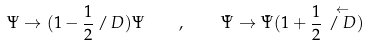Convert formula to latex. <formula><loc_0><loc_0><loc_500><loc_500>\Psi \rightarrow ( 1 - \frac { 1 } { 2 } \, { \slash \, D } ) \Psi \quad , \quad \bar { \Psi } \rightarrow \bar { \Psi } ( 1 + \frac { 1 } { 2 } \, \stackrel { \leftarrow } { \slash \, D } )</formula> 